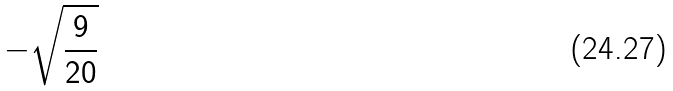Convert formula to latex. <formula><loc_0><loc_0><loc_500><loc_500>- \sqrt { \frac { 9 } { 2 0 } }</formula> 